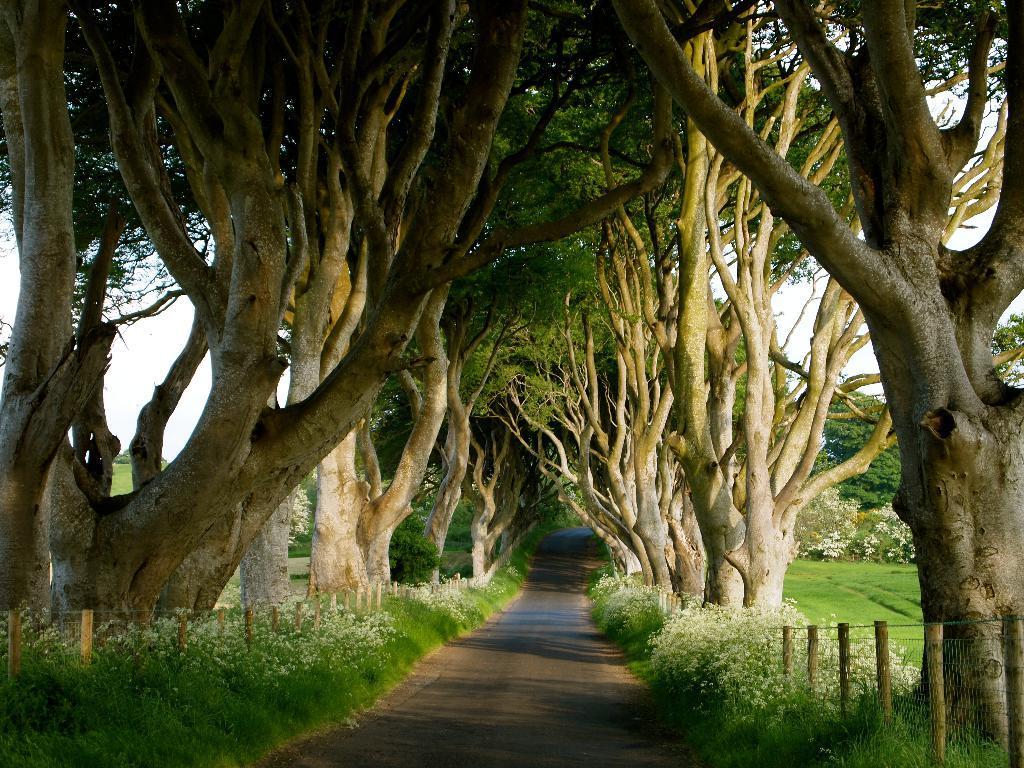Could you give a brief overview of what you see in this image? In this picture we can see a road. On the left and right side of the road, there are fences, trees and grass. Behind the trees, there is the sky. 